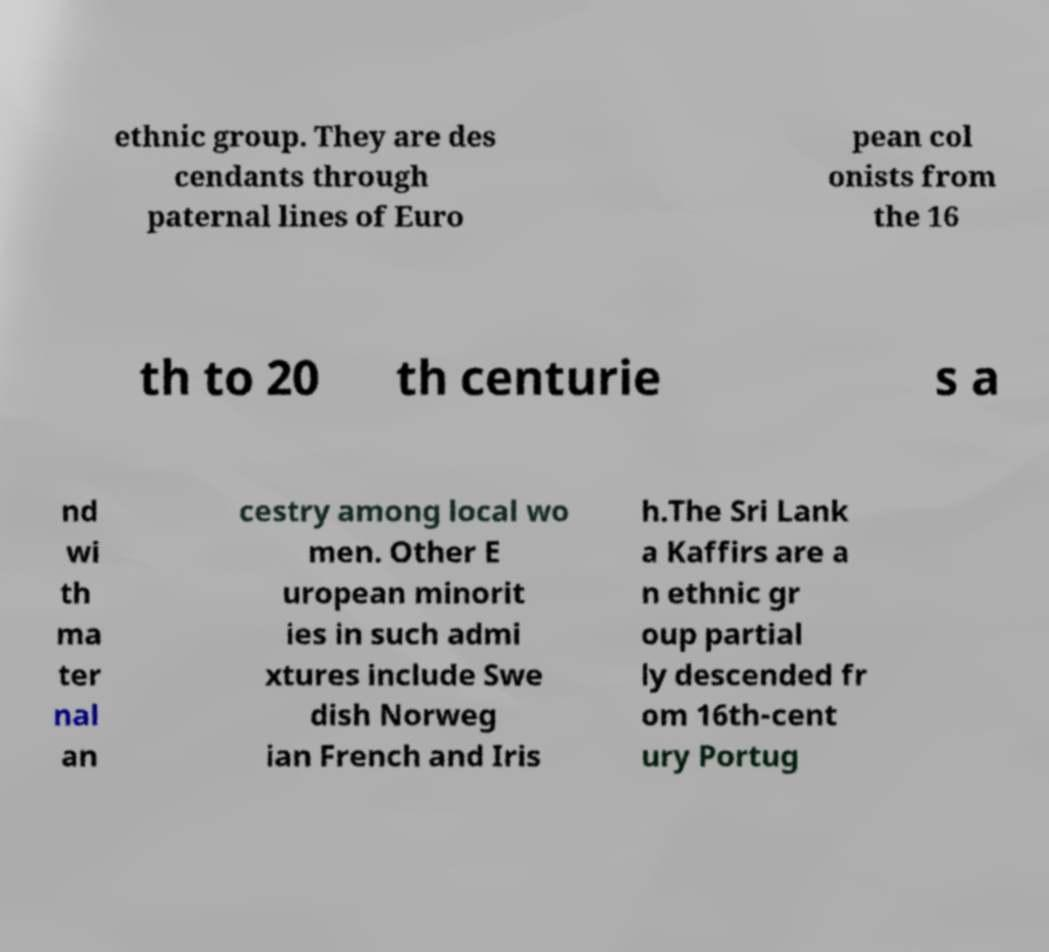Can you accurately transcribe the text from the provided image for me? ethnic group. They are des cendants through paternal lines of Euro pean col onists from the 16 th to 20 th centurie s a nd wi th ma ter nal an cestry among local wo men. Other E uropean minorit ies in such admi xtures include Swe dish Norweg ian French and Iris h.The Sri Lank a Kaffirs are a n ethnic gr oup partial ly descended fr om 16th-cent ury Portug 